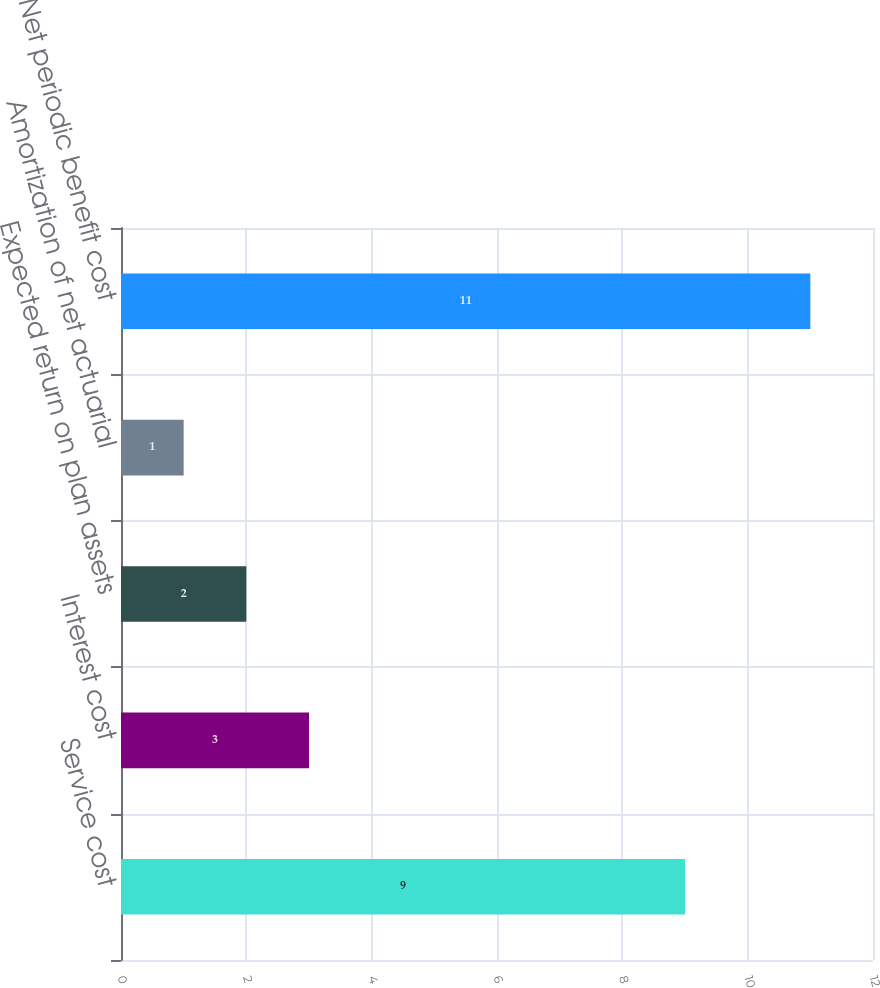<chart> <loc_0><loc_0><loc_500><loc_500><bar_chart><fcel>Service cost<fcel>Interest cost<fcel>Expected return on plan assets<fcel>Amortization of net actuarial<fcel>Net periodic benefit cost<nl><fcel>9<fcel>3<fcel>2<fcel>1<fcel>11<nl></chart> 